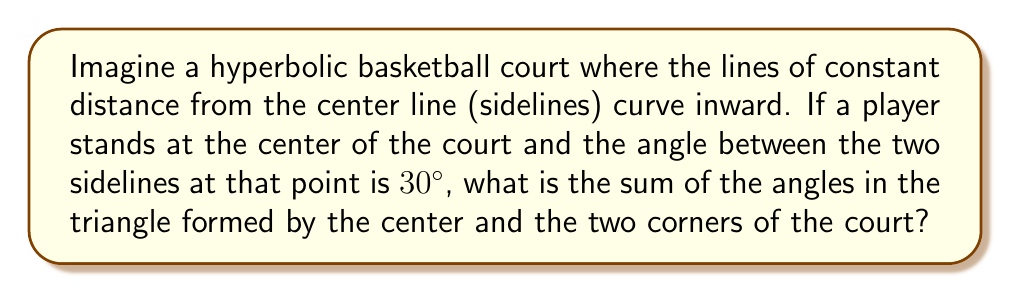Teach me how to tackle this problem. Let's approach this step-by-step:

1) In Euclidean geometry, we know that the sum of angles in a triangle is always 180°. However, this doesn't hold true in hyperbolic geometry.

2) In hyperbolic geometry, the sum of angles in a triangle is always less than 180°. The difference between 180° and the sum of the angles is called the defect.

3) The defect is directly related to the area of the triangle in hyperbolic space. The larger the area, the greater the defect.

4) In this case, we're dealing with an isosceles triangle, as the two sides from the center to the corners are equal (they're radii of the court).

5) Let's call the angle at the center $\theta$ and each of the base angles $\alpha$.

6) We know that $\theta = 30°$ (given in the question).

7) In hyperbolic geometry, parallel lines diverge, so the sidelines (which are hyperbolic parallels) will meet the baseline at right angles (90°).

8) Therefore, each base angle $\alpha$ will be less than 90°. Let's say it's $90° - x$, where $x$ is some positive value.

9) The sum of angles in this hyperbolic triangle is:

   $S = \theta + 2\alpha = 30° + 2(90° - x) = 210° - 2x$

10) Since we know this sum must be less than 180° in hyperbolic geometry:

    $210° - 2x < 180°$
    $-2x < -30°$
    $x > 15°$

11) Therefore, each base angle is less than 75° $(90° - 15°)$.

12) The exact sum will depend on the specific curvature of the hyperbolic space, which isn't provided in the question. However, we can conclude that the sum will be greater than 150° $(30° + 2(60°))$ and less than 180°.
Answer: Greater than 150° and less than 180° 